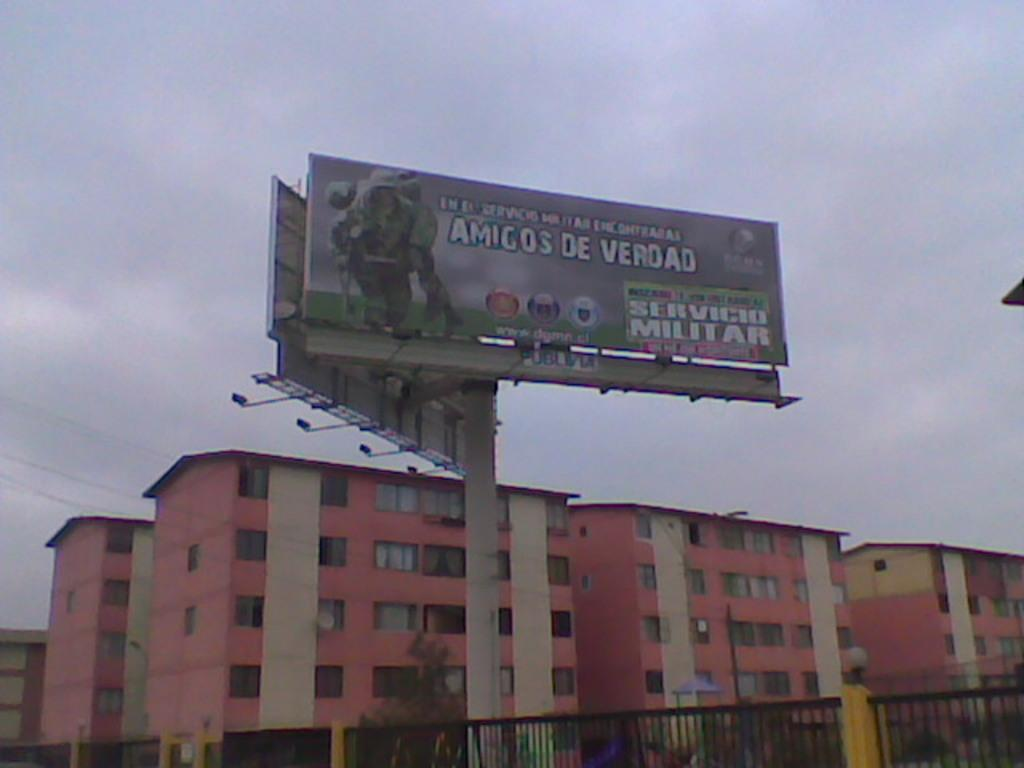<image>
Present a compact description of the photo's key features. A sign above la building advertises Amigo's de Verdad. 